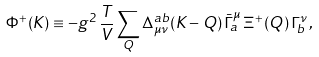Convert formula to latex. <formula><loc_0><loc_0><loc_500><loc_500>\Phi ^ { + } ( K ) \equiv - g ^ { 2 } \, \frac { T } { V } \sum _ { Q } \Delta ^ { a b } _ { \mu \nu } ( K - Q ) \, \bar { \Gamma } ^ { \mu } _ { a } \, \Xi ^ { + } ( Q ) \, \Gamma ^ { \nu } _ { b } \, ,</formula> 